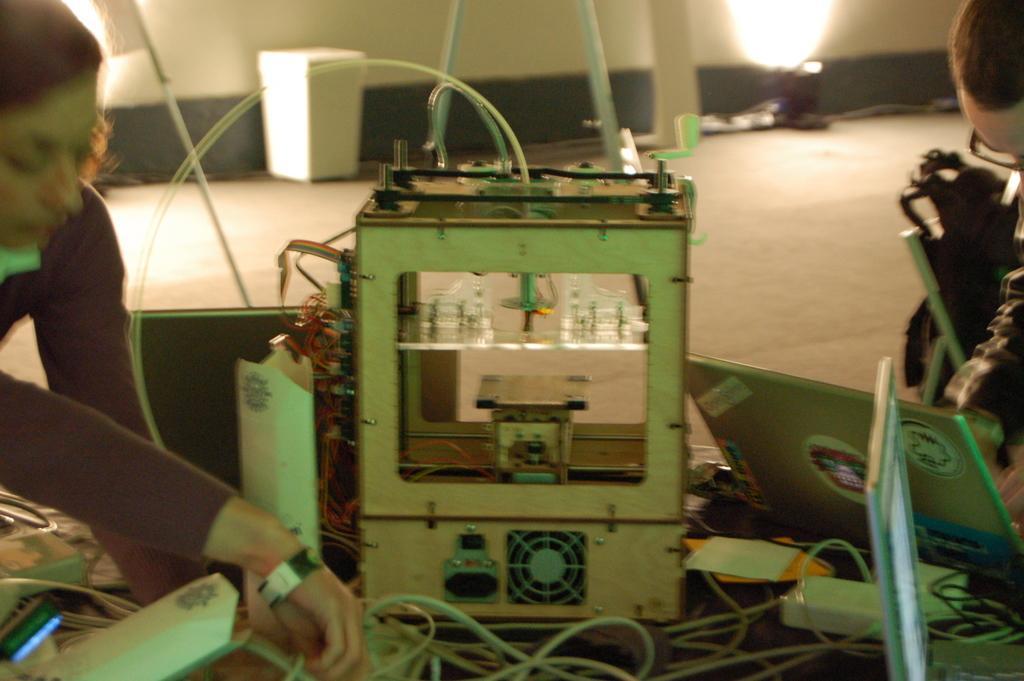How would you summarize this image in a sentence or two? In this picture we can observe device on the floor. We can observe some wires. We can observe two members on either sides of the picture. In the background there is a light and a wall. 